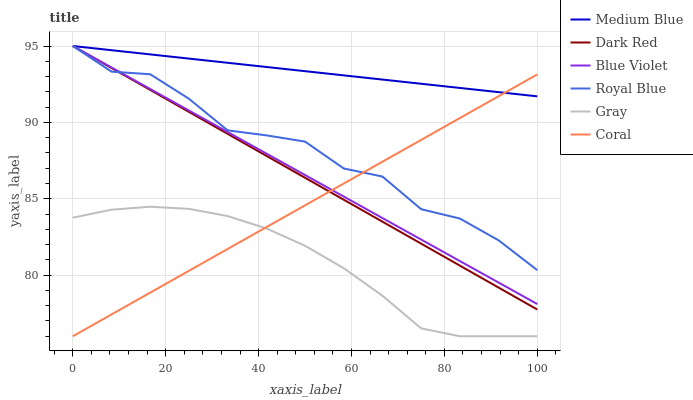Does Gray have the minimum area under the curve?
Answer yes or no. Yes. Does Medium Blue have the maximum area under the curve?
Answer yes or no. Yes. Does Dark Red have the minimum area under the curve?
Answer yes or no. No. Does Dark Red have the maximum area under the curve?
Answer yes or no. No. Is Medium Blue the smoothest?
Answer yes or no. Yes. Is Royal Blue the roughest?
Answer yes or no. Yes. Is Dark Red the smoothest?
Answer yes or no. No. Is Dark Red the roughest?
Answer yes or no. No. Does Dark Red have the lowest value?
Answer yes or no. No. Does Blue Violet have the highest value?
Answer yes or no. Yes. Does Coral have the highest value?
Answer yes or no. No. Is Gray less than Royal Blue?
Answer yes or no. Yes. Is Blue Violet greater than Gray?
Answer yes or no. Yes. Does Medium Blue intersect Royal Blue?
Answer yes or no. Yes. Is Medium Blue less than Royal Blue?
Answer yes or no. No. Is Medium Blue greater than Royal Blue?
Answer yes or no. No. Does Gray intersect Royal Blue?
Answer yes or no. No. 